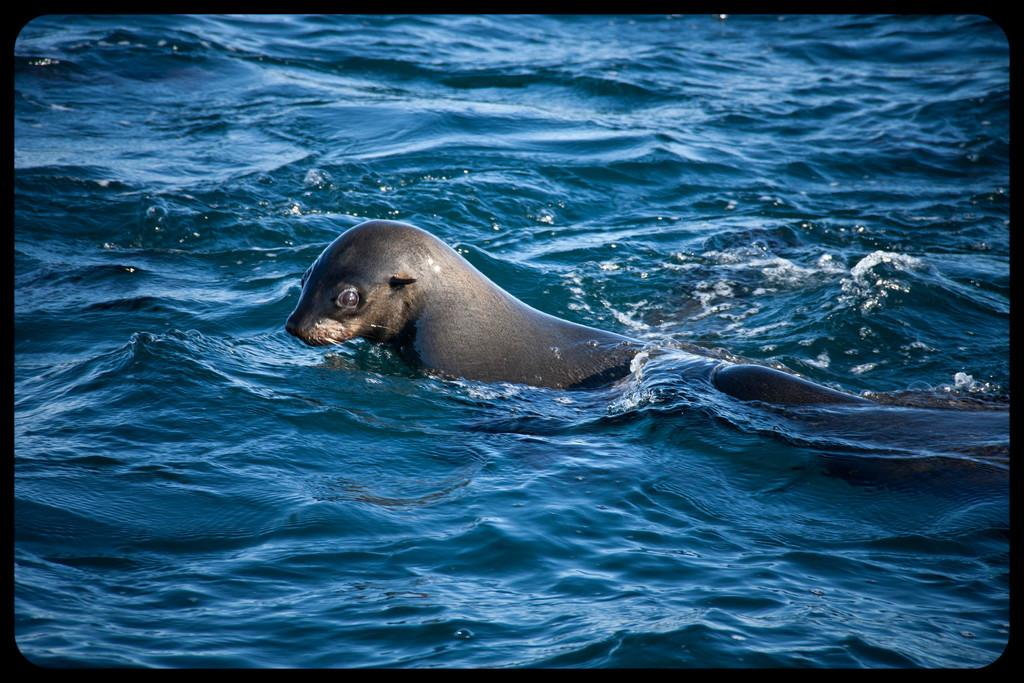What animal is present in the image? There is a seal in the image. What is the seal doing in the image? The seal is swimming in the water. What type of authority does the seal have in the image? The image does not depict any authority figures or situations involving authority. What can the seal open with its paws in the image? There is no can present in the image for the seal to interact with. 